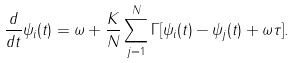Convert formula to latex. <formula><loc_0><loc_0><loc_500><loc_500>\frac { d } { d t } \psi _ { i } ( t ) = \omega + \frac { K } { N } \sum ^ { N } _ { j = 1 } \Gamma [ \psi _ { i } ( t ) - \psi _ { j } ( t ) + \omega \tau ] .</formula> 